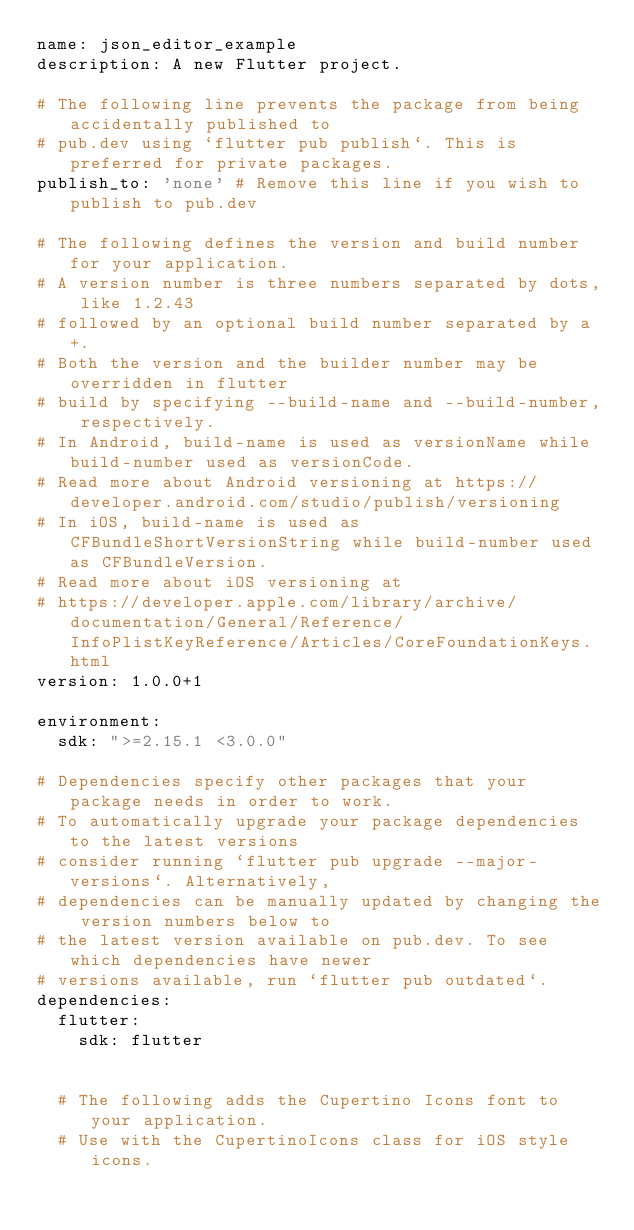Convert code to text. <code><loc_0><loc_0><loc_500><loc_500><_YAML_>name: json_editor_example
description: A new Flutter project.

# The following line prevents the package from being accidentally published to
# pub.dev using `flutter pub publish`. This is preferred for private packages.
publish_to: 'none' # Remove this line if you wish to publish to pub.dev

# The following defines the version and build number for your application.
# A version number is three numbers separated by dots, like 1.2.43
# followed by an optional build number separated by a +.
# Both the version and the builder number may be overridden in flutter
# build by specifying --build-name and --build-number, respectively.
# In Android, build-name is used as versionName while build-number used as versionCode.
# Read more about Android versioning at https://developer.android.com/studio/publish/versioning
# In iOS, build-name is used as CFBundleShortVersionString while build-number used as CFBundleVersion.
# Read more about iOS versioning at
# https://developer.apple.com/library/archive/documentation/General/Reference/InfoPlistKeyReference/Articles/CoreFoundationKeys.html
version: 1.0.0+1

environment:
  sdk: ">=2.15.1 <3.0.0"

# Dependencies specify other packages that your package needs in order to work.
# To automatically upgrade your package dependencies to the latest versions
# consider running `flutter pub upgrade --major-versions`. Alternatively,
# dependencies can be manually updated by changing the version numbers below to
# the latest version available on pub.dev. To see which dependencies have newer
# versions available, run `flutter pub outdated`.
dependencies:
  flutter:
    sdk: flutter


  # The following adds the Cupertino Icons font to your application.
  # Use with the CupertinoIcons class for iOS style icons.</code> 